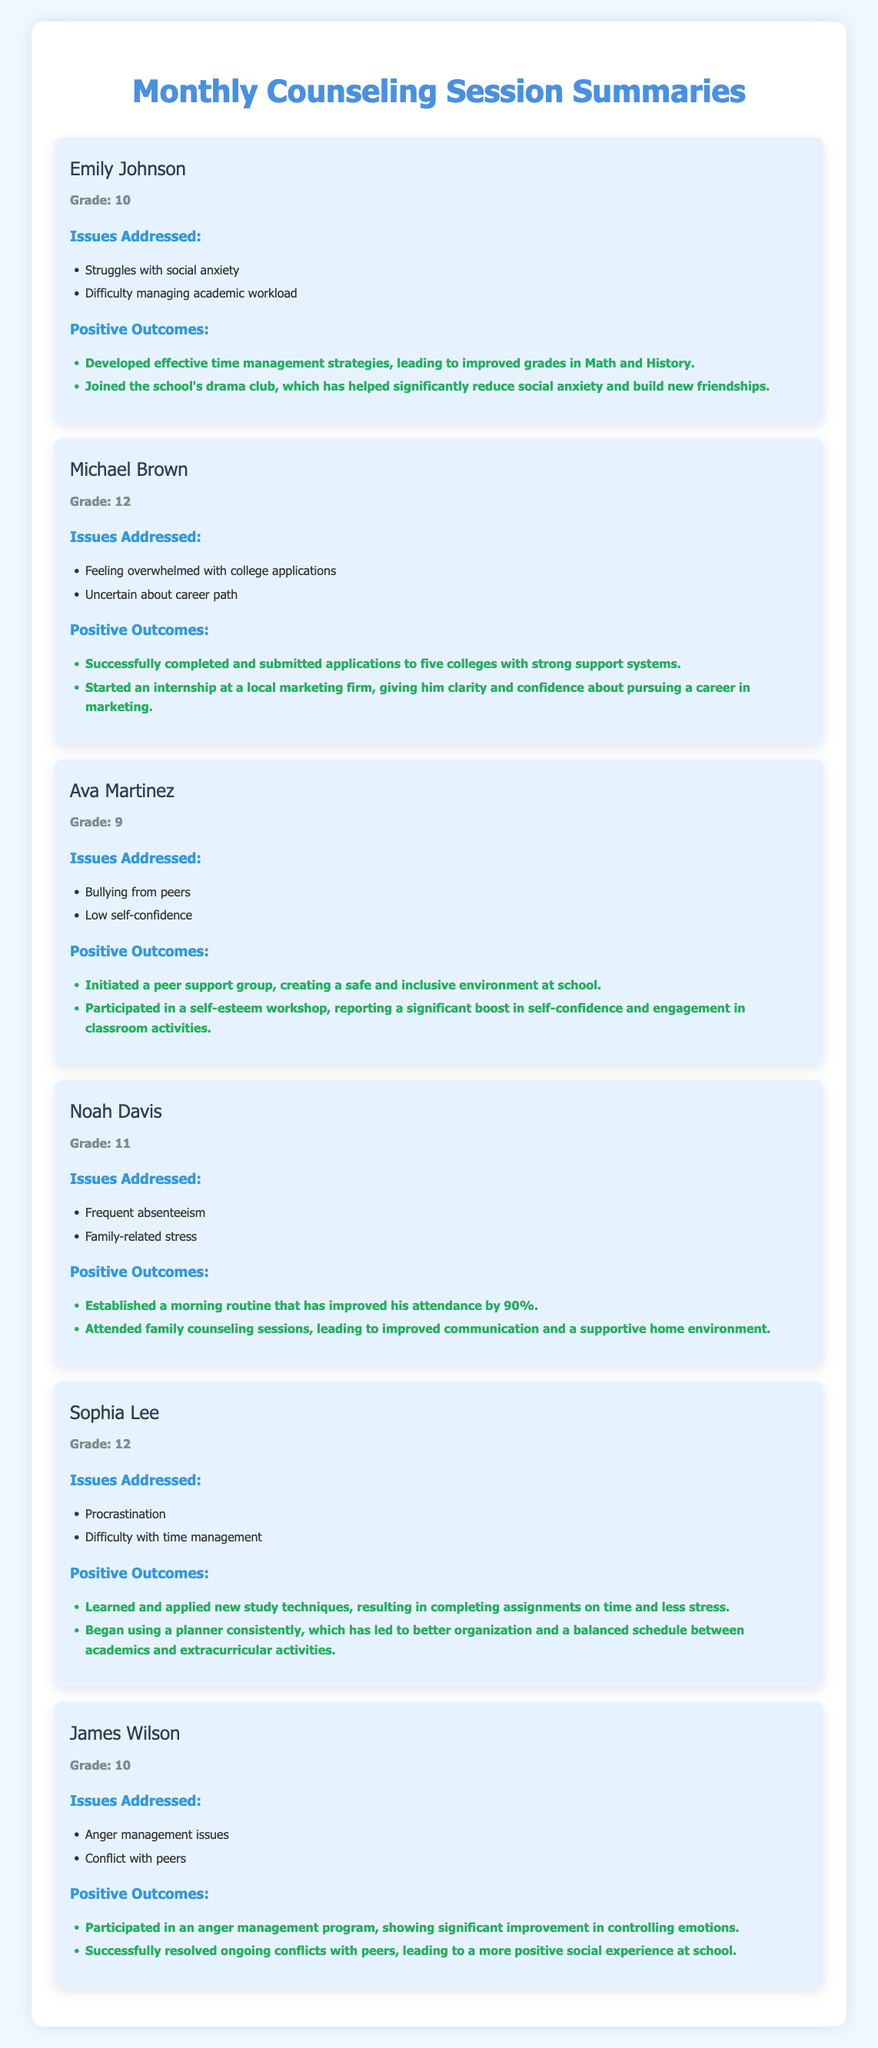What is the name of the student in Grade 10? The document provides the name of a student in Grade 10, which is "Emily Johnson".
Answer: Emily Johnson How many students are in this summary? The document lists a total of six students with their respective issues and outcomes highlighted.
Answer: Six What issue did Ava Martinez face? Ava Martinez faced issues related to "Bullying from peers" and "Low self-confidence".
Answer: Bullying from peers What positive outcome did Noah Davis achieve related to attendance? The document mentions that Noah Davis improved his attendance by establishing a morning routine.
Answer: Improved attendance by 90% Who initiated a peer support group? The document highlights that Ava Martinez initiated a peer support group.
Answer: Ava Martinez What student is participating in an internship? The document states that Michael Brown started an internship at a local marketing firm.
Answer: Michael Brown What grade is Sophia Lee in? Sophia Lee is listed as being in Grade 12 in the document.
Answer: Grade 12 Which student developed time management strategies? The document indicates that Emily Johnson developed effective time management strategies.
Answer: Emily Johnson What specific program did James Wilson participate in? The document mentions that James Wilson participated in an anger management program.
Answer: Anger management program 